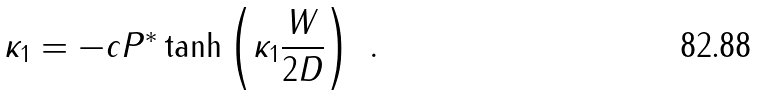<formula> <loc_0><loc_0><loc_500><loc_500>\kappa _ { 1 } = - c P ^ { * } \tanh \left ( \kappa _ { 1 } \frac { W } { 2 D } \right ) \ .</formula> 